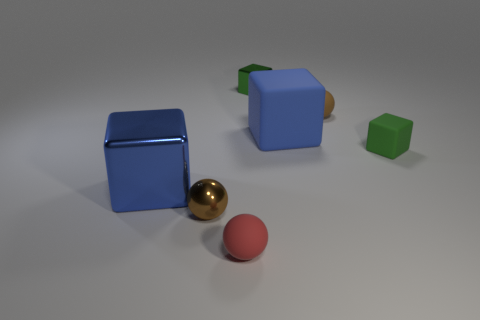There is a small shiny sphere; is it the same color as the matte sphere that is behind the small red thing?
Your response must be concise. Yes. What is the shape of the tiny rubber object that is the same color as the metallic ball?
Your answer should be compact. Sphere. Are there any other things that are the same size as the brown shiny thing?
Offer a terse response. Yes. What number of large metal cubes have the same color as the big matte thing?
Make the answer very short. 1. Are the tiny red sphere and the tiny brown ball on the right side of the red matte thing made of the same material?
Make the answer very short. Yes. What number of large blocks are the same material as the red object?
Offer a very short reply. 1. What is the shape of the blue thing on the right side of the large blue shiny cube?
Provide a succinct answer. Cube. Is the material of the brown ball that is in front of the green rubber object the same as the brown ball that is right of the green metallic thing?
Your answer should be compact. No. Is there a big brown rubber thing of the same shape as the big shiny thing?
Your response must be concise. No. How many things are tiny rubber balls that are right of the green metallic object or tiny brown matte things?
Offer a very short reply. 1. 